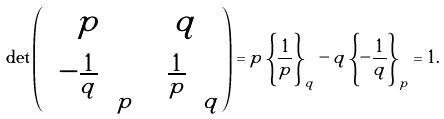<formula> <loc_0><loc_0><loc_500><loc_500>\det \begin{pmatrix} p & q \\ \left \{ - \frac { 1 } { q } \right \} _ { p } & \left \{ \frac { 1 } { p } \right \} _ { q } \end{pmatrix} = p \left \{ \frac { 1 } { p } \right \} _ { q } - q \left \{ - \frac { 1 } { q } \right \} _ { p } = 1 .</formula> 